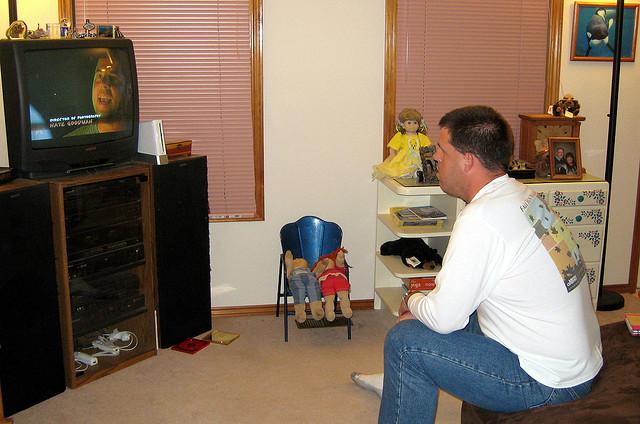Are the people playing a game?
Give a very brief answer. No. Is the TV turned on?
Give a very brief answer. Yes. Is this person watching a movie?
Quick response, please. Yes. What is in the blue chair?
Keep it brief. Teddy bears. What type of footwear is the person wearing?
Give a very brief answer. Socks. 